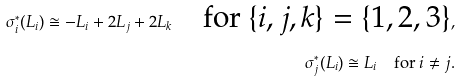<formula> <loc_0><loc_0><loc_500><loc_500>\sigma _ { i } ^ { * } ( L _ { i } ) \cong - L _ { i } + 2 L _ { j } + 2 L _ { k } \quad \text {for $\{i,j,k\}=\{1,2,3\}$} , \\ \sigma _ { j } ^ { * } ( L _ { i } ) \cong L _ { i } \quad \text {for $i\neq j$} .</formula> 